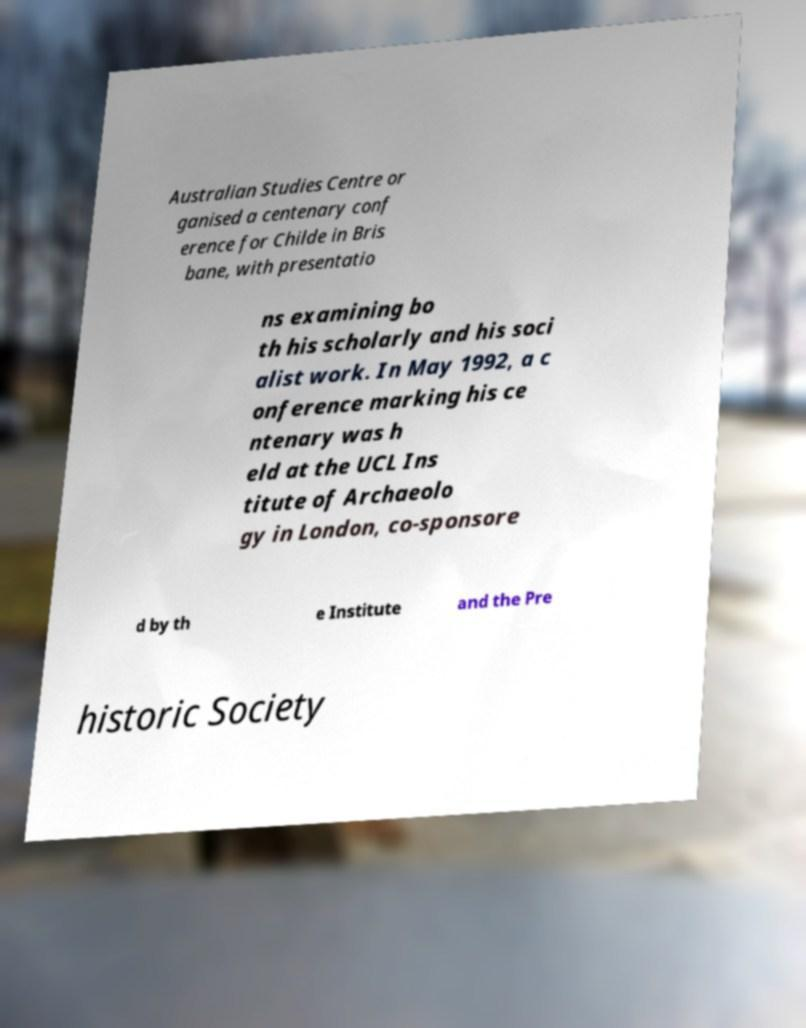For documentation purposes, I need the text within this image transcribed. Could you provide that? Australian Studies Centre or ganised a centenary conf erence for Childe in Bris bane, with presentatio ns examining bo th his scholarly and his soci alist work. In May 1992, a c onference marking his ce ntenary was h eld at the UCL Ins titute of Archaeolo gy in London, co-sponsore d by th e Institute and the Pre historic Society 